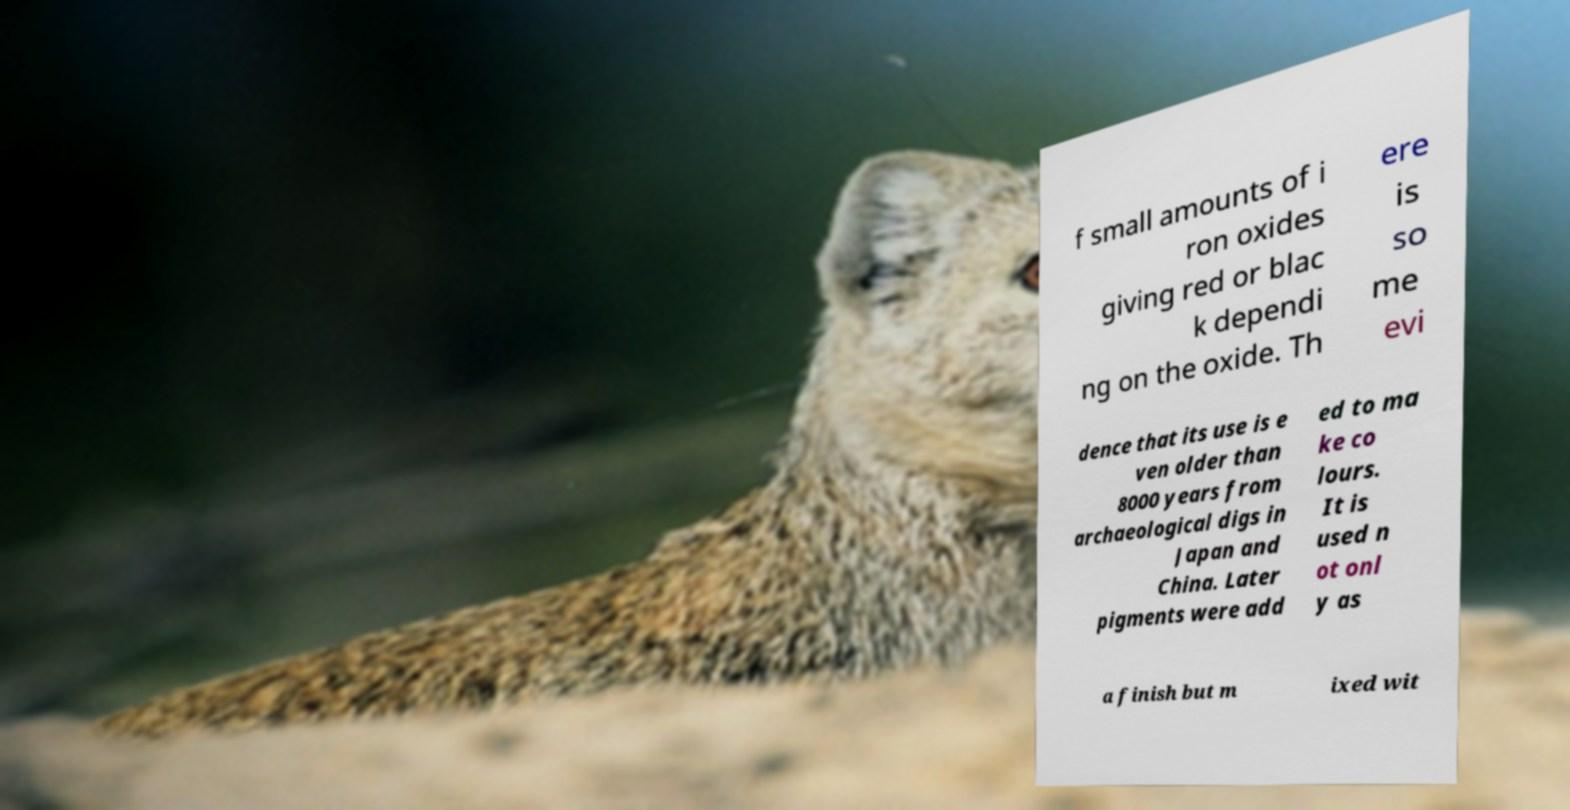There's text embedded in this image that I need extracted. Can you transcribe it verbatim? f small amounts of i ron oxides giving red or blac k dependi ng on the oxide. Th ere is so me evi dence that its use is e ven older than 8000 years from archaeological digs in Japan and China. Later pigments were add ed to ma ke co lours. It is used n ot onl y as a finish but m ixed wit 